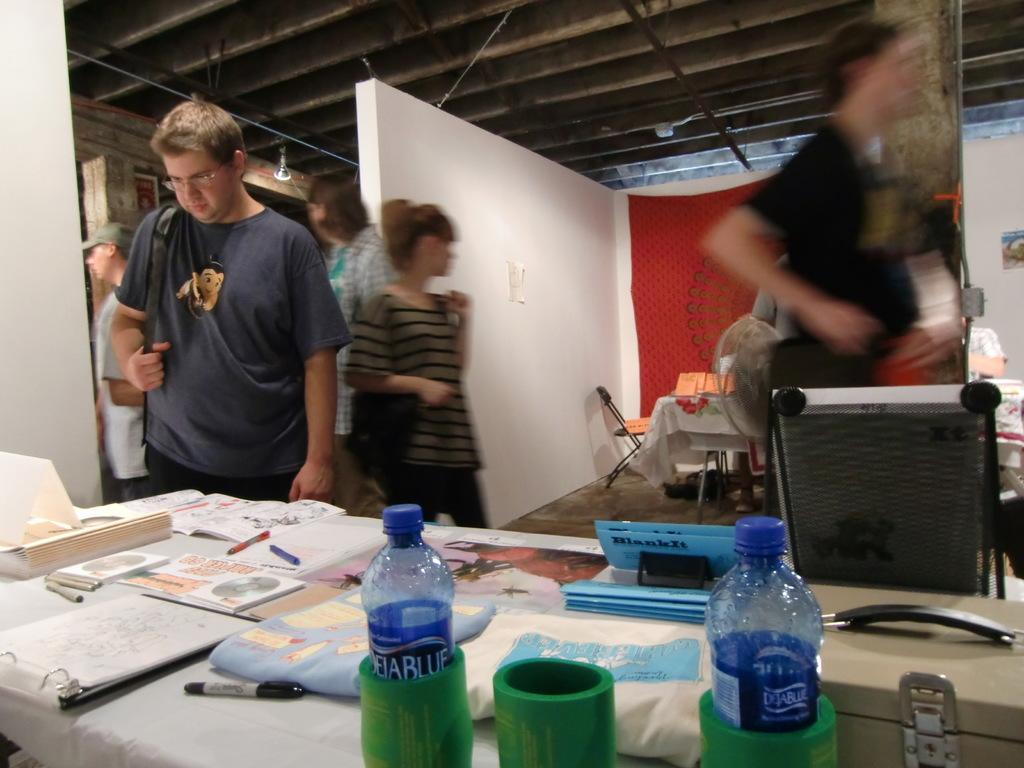<image>
Write a terse but informative summary of the picture. People looking on a table with Dejablue water bottles on them. 